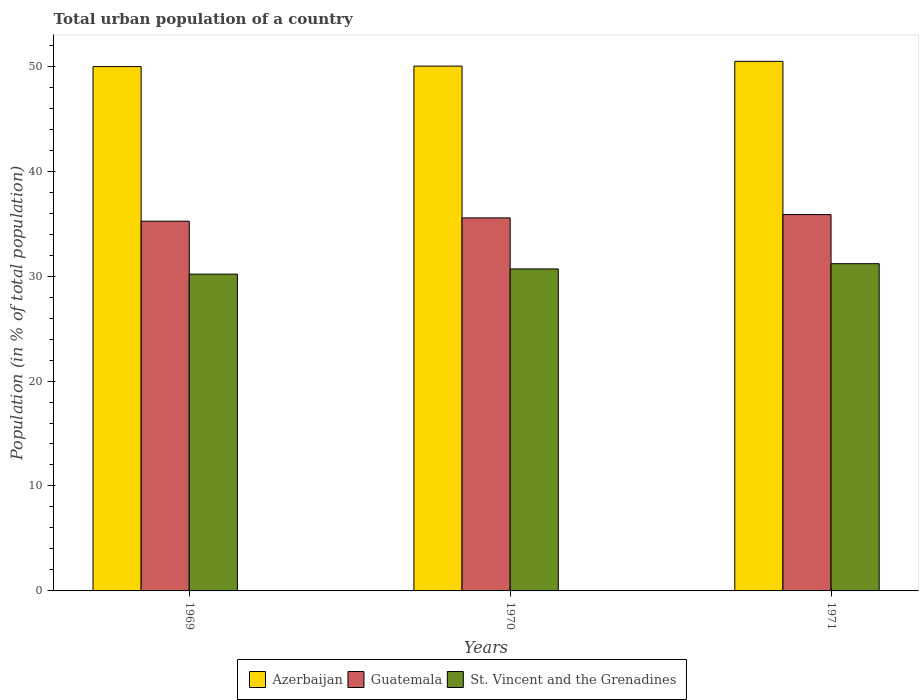How many bars are there on the 1st tick from the left?
Ensure brevity in your answer.  3. How many bars are there on the 3rd tick from the right?
Provide a succinct answer. 3. What is the label of the 1st group of bars from the left?
Offer a very short reply. 1969. In how many cases, is the number of bars for a given year not equal to the number of legend labels?
Provide a short and direct response. 0. What is the urban population in Guatemala in 1970?
Give a very brief answer. 35.55. Across all years, what is the maximum urban population in Guatemala?
Offer a terse response. 35.86. Across all years, what is the minimum urban population in Guatemala?
Provide a succinct answer. 35.23. In which year was the urban population in Azerbaijan minimum?
Provide a short and direct response. 1969. What is the total urban population in Guatemala in the graph?
Give a very brief answer. 106.64. What is the difference between the urban population in St. Vincent and the Grenadines in 1969 and that in 1970?
Give a very brief answer. -0.5. What is the difference between the urban population in Azerbaijan in 1969 and the urban population in Guatemala in 1971?
Offer a terse response. 14.1. What is the average urban population in Guatemala per year?
Offer a terse response. 35.55. In the year 1969, what is the difference between the urban population in Azerbaijan and urban population in St. Vincent and the Grenadines?
Your answer should be compact. 19.78. What is the ratio of the urban population in St. Vincent and the Grenadines in 1969 to that in 1970?
Your answer should be compact. 0.98. Is the difference between the urban population in Azerbaijan in 1970 and 1971 greater than the difference between the urban population in St. Vincent and the Grenadines in 1970 and 1971?
Provide a short and direct response. Yes. What is the difference between the highest and the second highest urban population in Azerbaijan?
Ensure brevity in your answer.  0.45. What is the difference between the highest and the lowest urban population in St. Vincent and the Grenadines?
Provide a short and direct response. 0.99. What does the 2nd bar from the left in 1970 represents?
Make the answer very short. Guatemala. What does the 1st bar from the right in 1969 represents?
Your answer should be compact. St. Vincent and the Grenadines. How many bars are there?
Your response must be concise. 9. Are all the bars in the graph horizontal?
Provide a short and direct response. No. Does the graph contain any zero values?
Your answer should be very brief. No. What is the title of the graph?
Provide a succinct answer. Total urban population of a country. What is the label or title of the X-axis?
Your response must be concise. Years. What is the label or title of the Y-axis?
Offer a terse response. Population (in % of total population). What is the Population (in % of total population) in Azerbaijan in 1969?
Your answer should be very brief. 49.96. What is the Population (in % of total population) in Guatemala in 1969?
Your response must be concise. 35.23. What is the Population (in % of total population) in St. Vincent and the Grenadines in 1969?
Your answer should be very brief. 30.19. What is the Population (in % of total population) of Azerbaijan in 1970?
Your answer should be very brief. 50.01. What is the Population (in % of total population) in Guatemala in 1970?
Offer a terse response. 35.55. What is the Population (in % of total population) in St. Vincent and the Grenadines in 1970?
Provide a short and direct response. 30.68. What is the Population (in % of total population) of Azerbaijan in 1971?
Offer a terse response. 50.46. What is the Population (in % of total population) in Guatemala in 1971?
Your answer should be very brief. 35.86. What is the Population (in % of total population) in St. Vincent and the Grenadines in 1971?
Keep it short and to the point. 31.18. Across all years, what is the maximum Population (in % of total population) of Azerbaijan?
Make the answer very short. 50.46. Across all years, what is the maximum Population (in % of total population) in Guatemala?
Offer a terse response. 35.86. Across all years, what is the maximum Population (in % of total population) in St. Vincent and the Grenadines?
Keep it short and to the point. 31.18. Across all years, what is the minimum Population (in % of total population) in Azerbaijan?
Keep it short and to the point. 49.96. Across all years, what is the minimum Population (in % of total population) of Guatemala?
Give a very brief answer. 35.23. Across all years, what is the minimum Population (in % of total population) in St. Vincent and the Grenadines?
Offer a terse response. 30.19. What is the total Population (in % of total population) in Azerbaijan in the graph?
Offer a very short reply. 150.43. What is the total Population (in % of total population) in Guatemala in the graph?
Your answer should be very brief. 106.64. What is the total Population (in % of total population) in St. Vincent and the Grenadines in the graph?
Ensure brevity in your answer.  92.05. What is the difference between the Population (in % of total population) of Azerbaijan in 1969 and that in 1970?
Keep it short and to the point. -0.04. What is the difference between the Population (in % of total population) of Guatemala in 1969 and that in 1970?
Your answer should be very brief. -0.31. What is the difference between the Population (in % of total population) in St. Vincent and the Grenadines in 1969 and that in 1970?
Offer a terse response. -0.5. What is the difference between the Population (in % of total population) of Azerbaijan in 1969 and that in 1971?
Provide a succinct answer. -0.5. What is the difference between the Population (in % of total population) of Guatemala in 1969 and that in 1971?
Your answer should be very brief. -0.63. What is the difference between the Population (in % of total population) of St. Vincent and the Grenadines in 1969 and that in 1971?
Provide a short and direct response. -0.99. What is the difference between the Population (in % of total population) in Azerbaijan in 1970 and that in 1971?
Ensure brevity in your answer.  -0.45. What is the difference between the Population (in % of total population) of Guatemala in 1970 and that in 1971?
Provide a short and direct response. -0.32. What is the difference between the Population (in % of total population) of St. Vincent and the Grenadines in 1970 and that in 1971?
Give a very brief answer. -0.5. What is the difference between the Population (in % of total population) of Azerbaijan in 1969 and the Population (in % of total population) of Guatemala in 1970?
Your response must be concise. 14.42. What is the difference between the Population (in % of total population) of Azerbaijan in 1969 and the Population (in % of total population) of St. Vincent and the Grenadines in 1970?
Give a very brief answer. 19.28. What is the difference between the Population (in % of total population) of Guatemala in 1969 and the Population (in % of total population) of St. Vincent and the Grenadines in 1970?
Make the answer very short. 4.55. What is the difference between the Population (in % of total population) of Azerbaijan in 1969 and the Population (in % of total population) of Guatemala in 1971?
Offer a very short reply. 14.1. What is the difference between the Population (in % of total population) in Azerbaijan in 1969 and the Population (in % of total population) in St. Vincent and the Grenadines in 1971?
Provide a short and direct response. 18.78. What is the difference between the Population (in % of total population) in Guatemala in 1969 and the Population (in % of total population) in St. Vincent and the Grenadines in 1971?
Make the answer very short. 4.05. What is the difference between the Population (in % of total population) of Azerbaijan in 1970 and the Population (in % of total population) of Guatemala in 1971?
Your answer should be very brief. 14.15. What is the difference between the Population (in % of total population) of Azerbaijan in 1970 and the Population (in % of total population) of St. Vincent and the Grenadines in 1971?
Provide a succinct answer. 18.83. What is the difference between the Population (in % of total population) in Guatemala in 1970 and the Population (in % of total population) in St. Vincent and the Grenadines in 1971?
Provide a succinct answer. 4.36. What is the average Population (in % of total population) in Azerbaijan per year?
Ensure brevity in your answer.  50.14. What is the average Population (in % of total population) of Guatemala per year?
Offer a terse response. 35.55. What is the average Population (in % of total population) in St. Vincent and the Grenadines per year?
Offer a very short reply. 30.68. In the year 1969, what is the difference between the Population (in % of total population) of Azerbaijan and Population (in % of total population) of Guatemala?
Provide a short and direct response. 14.73. In the year 1969, what is the difference between the Population (in % of total population) of Azerbaijan and Population (in % of total population) of St. Vincent and the Grenadines?
Give a very brief answer. 19.78. In the year 1969, what is the difference between the Population (in % of total population) in Guatemala and Population (in % of total population) in St. Vincent and the Grenadines?
Your response must be concise. 5.04. In the year 1970, what is the difference between the Population (in % of total population) of Azerbaijan and Population (in % of total population) of Guatemala?
Provide a succinct answer. 14.46. In the year 1970, what is the difference between the Population (in % of total population) in Azerbaijan and Population (in % of total population) in St. Vincent and the Grenadines?
Your answer should be compact. 19.32. In the year 1970, what is the difference between the Population (in % of total population) of Guatemala and Population (in % of total population) of St. Vincent and the Grenadines?
Give a very brief answer. 4.86. In the year 1971, what is the difference between the Population (in % of total population) in Azerbaijan and Population (in % of total population) in Guatemala?
Offer a terse response. 14.6. In the year 1971, what is the difference between the Population (in % of total population) in Azerbaijan and Population (in % of total population) in St. Vincent and the Grenadines?
Your response must be concise. 19.28. In the year 1971, what is the difference between the Population (in % of total population) in Guatemala and Population (in % of total population) in St. Vincent and the Grenadines?
Keep it short and to the point. 4.68. What is the ratio of the Population (in % of total population) of St. Vincent and the Grenadines in 1969 to that in 1970?
Provide a short and direct response. 0.98. What is the ratio of the Population (in % of total population) in Azerbaijan in 1969 to that in 1971?
Ensure brevity in your answer.  0.99. What is the ratio of the Population (in % of total population) of Guatemala in 1969 to that in 1971?
Offer a very short reply. 0.98. What is the ratio of the Population (in % of total population) in St. Vincent and the Grenadines in 1969 to that in 1971?
Keep it short and to the point. 0.97. What is the ratio of the Population (in % of total population) in Azerbaijan in 1970 to that in 1971?
Offer a terse response. 0.99. What is the difference between the highest and the second highest Population (in % of total population) of Azerbaijan?
Give a very brief answer. 0.45. What is the difference between the highest and the second highest Population (in % of total population) of Guatemala?
Your response must be concise. 0.32. What is the difference between the highest and the second highest Population (in % of total population) of St. Vincent and the Grenadines?
Make the answer very short. 0.5. What is the difference between the highest and the lowest Population (in % of total population) in Azerbaijan?
Provide a short and direct response. 0.5. What is the difference between the highest and the lowest Population (in % of total population) in Guatemala?
Your answer should be very brief. 0.63. 